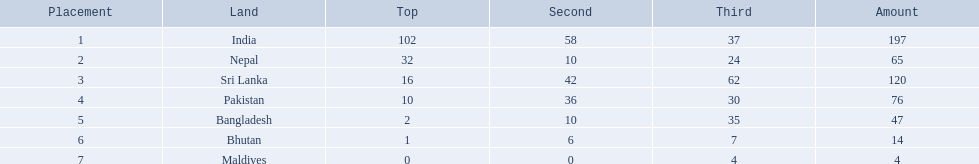How many gold medals were won by the teams? 102, 32, 16, 10, 2, 1, 0. What country won no gold medals? Maldives. 